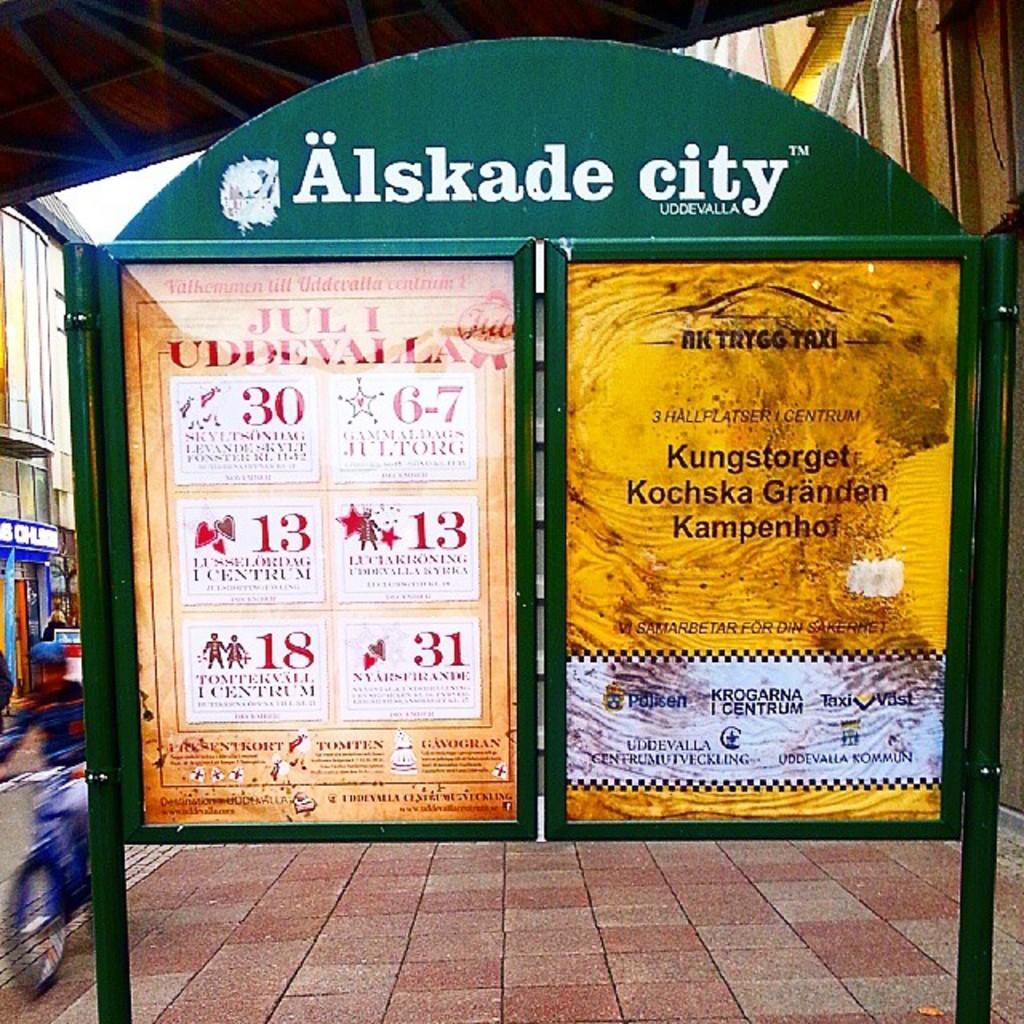Describe this image in one or two sentences. In this image I can see the board. To the side of the board I can see the person riding the bicycle which is in blue color. The person is wearing the cap. In the back I can see the building and there are boards to it. I can also see the roof and sky in the back. 